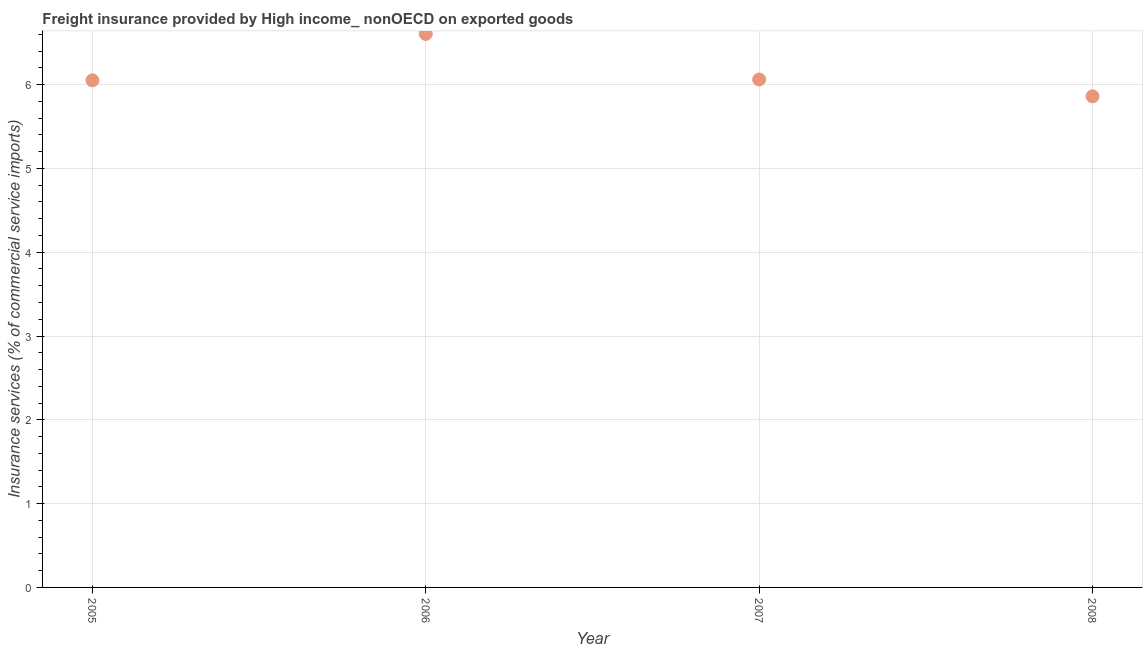What is the freight insurance in 2006?
Your response must be concise. 6.6. Across all years, what is the maximum freight insurance?
Your answer should be compact. 6.6. Across all years, what is the minimum freight insurance?
Provide a short and direct response. 5.86. In which year was the freight insurance maximum?
Provide a short and direct response. 2006. What is the sum of the freight insurance?
Provide a short and direct response. 24.58. What is the difference between the freight insurance in 2007 and 2008?
Keep it short and to the point. 0.2. What is the average freight insurance per year?
Your response must be concise. 6.14. What is the median freight insurance?
Offer a very short reply. 6.06. In how many years, is the freight insurance greater than 0.6000000000000001 %?
Keep it short and to the point. 4. What is the ratio of the freight insurance in 2006 to that in 2008?
Ensure brevity in your answer.  1.13. Is the freight insurance in 2006 less than that in 2007?
Provide a succinct answer. No. What is the difference between the highest and the second highest freight insurance?
Provide a succinct answer. 0.54. What is the difference between the highest and the lowest freight insurance?
Keep it short and to the point. 0.74. In how many years, is the freight insurance greater than the average freight insurance taken over all years?
Offer a terse response. 1. How many years are there in the graph?
Provide a short and direct response. 4. Are the values on the major ticks of Y-axis written in scientific E-notation?
Offer a very short reply. No. Does the graph contain any zero values?
Provide a short and direct response. No. Does the graph contain grids?
Provide a short and direct response. Yes. What is the title of the graph?
Ensure brevity in your answer.  Freight insurance provided by High income_ nonOECD on exported goods . What is the label or title of the Y-axis?
Keep it short and to the point. Insurance services (% of commercial service imports). What is the Insurance services (% of commercial service imports) in 2005?
Ensure brevity in your answer.  6.05. What is the Insurance services (% of commercial service imports) in 2006?
Provide a short and direct response. 6.6. What is the Insurance services (% of commercial service imports) in 2007?
Provide a succinct answer. 6.06. What is the Insurance services (% of commercial service imports) in 2008?
Make the answer very short. 5.86. What is the difference between the Insurance services (% of commercial service imports) in 2005 and 2006?
Your answer should be compact. -0.55. What is the difference between the Insurance services (% of commercial service imports) in 2005 and 2007?
Ensure brevity in your answer.  -0.01. What is the difference between the Insurance services (% of commercial service imports) in 2005 and 2008?
Keep it short and to the point. 0.19. What is the difference between the Insurance services (% of commercial service imports) in 2006 and 2007?
Your response must be concise. 0.54. What is the difference between the Insurance services (% of commercial service imports) in 2006 and 2008?
Offer a terse response. 0.74. What is the difference between the Insurance services (% of commercial service imports) in 2007 and 2008?
Give a very brief answer. 0.2. What is the ratio of the Insurance services (% of commercial service imports) in 2005 to that in 2006?
Your response must be concise. 0.92. What is the ratio of the Insurance services (% of commercial service imports) in 2005 to that in 2008?
Keep it short and to the point. 1.03. What is the ratio of the Insurance services (% of commercial service imports) in 2006 to that in 2007?
Offer a very short reply. 1.09. What is the ratio of the Insurance services (% of commercial service imports) in 2006 to that in 2008?
Ensure brevity in your answer.  1.13. What is the ratio of the Insurance services (% of commercial service imports) in 2007 to that in 2008?
Offer a very short reply. 1.03. 